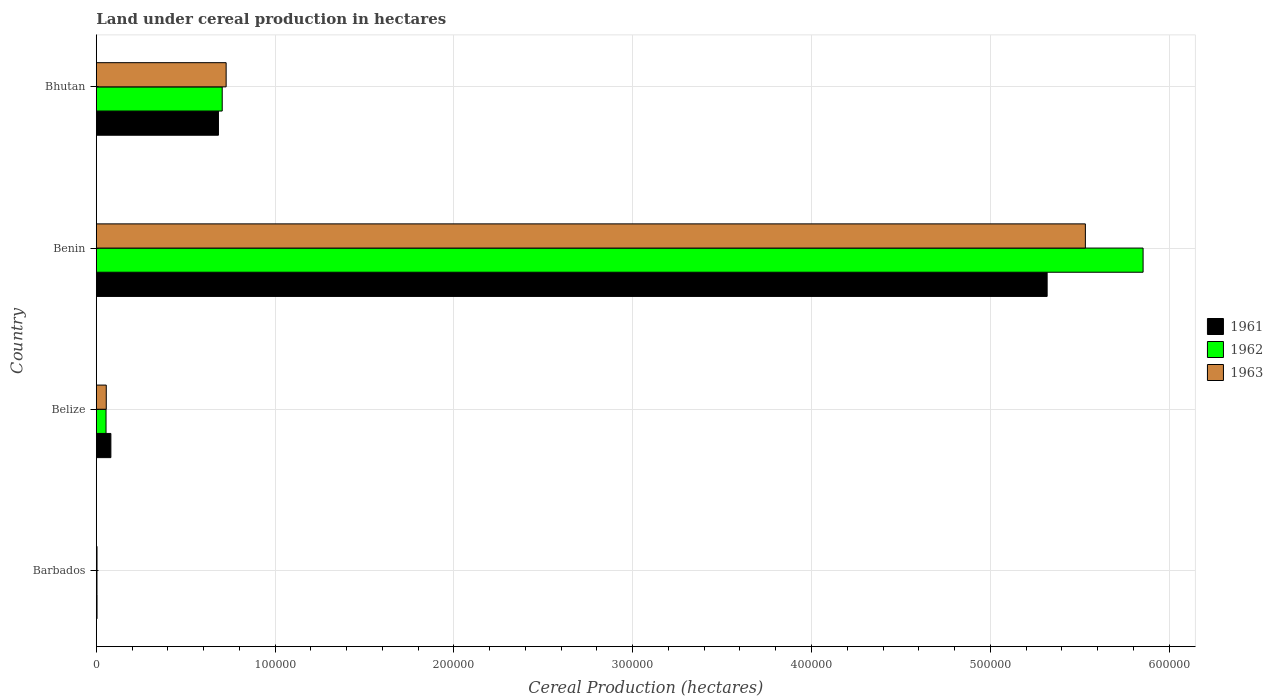How many groups of bars are there?
Provide a short and direct response. 4. How many bars are there on the 4th tick from the top?
Your response must be concise. 3. How many bars are there on the 4th tick from the bottom?
Keep it short and to the point. 3. What is the label of the 4th group of bars from the top?
Provide a short and direct response. Barbados. In how many cases, is the number of bars for a given country not equal to the number of legend labels?
Keep it short and to the point. 0. What is the land under cereal production in 1962 in Benin?
Provide a succinct answer. 5.85e+05. Across all countries, what is the maximum land under cereal production in 1963?
Make the answer very short. 5.53e+05. Across all countries, what is the minimum land under cereal production in 1962?
Ensure brevity in your answer.  358. In which country was the land under cereal production in 1962 maximum?
Keep it short and to the point. Benin. In which country was the land under cereal production in 1961 minimum?
Offer a very short reply. Barbados. What is the total land under cereal production in 1963 in the graph?
Offer a terse response. 6.32e+05. What is the difference between the land under cereal production in 1961 in Belize and that in Bhutan?
Provide a succinct answer. -6.02e+04. What is the difference between the land under cereal production in 1961 in Bhutan and the land under cereal production in 1963 in Barbados?
Provide a short and direct response. 6.79e+04. What is the average land under cereal production in 1962 per country?
Make the answer very short. 1.65e+05. What is the difference between the land under cereal production in 1961 and land under cereal production in 1962 in Benin?
Keep it short and to the point. -5.37e+04. What is the ratio of the land under cereal production in 1962 in Belize to that in Bhutan?
Give a very brief answer. 0.08. Is the difference between the land under cereal production in 1961 in Barbados and Bhutan greater than the difference between the land under cereal production in 1962 in Barbados and Bhutan?
Your answer should be compact. Yes. What is the difference between the highest and the second highest land under cereal production in 1962?
Your answer should be very brief. 5.15e+05. What is the difference between the highest and the lowest land under cereal production in 1962?
Keep it short and to the point. 5.85e+05. In how many countries, is the land under cereal production in 1961 greater than the average land under cereal production in 1961 taken over all countries?
Your answer should be compact. 1. Is the sum of the land under cereal production in 1963 in Barbados and Bhutan greater than the maximum land under cereal production in 1961 across all countries?
Give a very brief answer. No. How many bars are there?
Your answer should be compact. 12. How many countries are there in the graph?
Make the answer very short. 4. Are the values on the major ticks of X-axis written in scientific E-notation?
Make the answer very short. No. Does the graph contain grids?
Keep it short and to the point. Yes. Where does the legend appear in the graph?
Your response must be concise. Center right. How are the legend labels stacked?
Provide a succinct answer. Vertical. What is the title of the graph?
Ensure brevity in your answer.  Land under cereal production in hectares. Does "2012" appear as one of the legend labels in the graph?
Provide a short and direct response. No. What is the label or title of the X-axis?
Ensure brevity in your answer.  Cereal Production (hectares). What is the Cereal Production (hectares) of 1961 in Barbados?
Your answer should be compact. 380. What is the Cereal Production (hectares) in 1962 in Barbados?
Provide a short and direct response. 358. What is the Cereal Production (hectares) of 1963 in Barbados?
Give a very brief answer. 376. What is the Cereal Production (hectares) of 1961 in Belize?
Offer a terse response. 8129. What is the Cereal Production (hectares) in 1962 in Belize?
Your response must be concise. 5419. What is the Cereal Production (hectares) of 1963 in Belize?
Your response must be concise. 5550. What is the Cereal Production (hectares) in 1961 in Benin?
Offer a terse response. 5.32e+05. What is the Cereal Production (hectares) of 1962 in Benin?
Your answer should be compact. 5.85e+05. What is the Cereal Production (hectares) in 1963 in Benin?
Keep it short and to the point. 5.53e+05. What is the Cereal Production (hectares) of 1961 in Bhutan?
Make the answer very short. 6.83e+04. What is the Cereal Production (hectares) in 1962 in Bhutan?
Keep it short and to the point. 7.04e+04. What is the Cereal Production (hectares) of 1963 in Bhutan?
Ensure brevity in your answer.  7.26e+04. Across all countries, what is the maximum Cereal Production (hectares) in 1961?
Provide a short and direct response. 5.32e+05. Across all countries, what is the maximum Cereal Production (hectares) in 1962?
Offer a terse response. 5.85e+05. Across all countries, what is the maximum Cereal Production (hectares) of 1963?
Make the answer very short. 5.53e+05. Across all countries, what is the minimum Cereal Production (hectares) of 1961?
Offer a terse response. 380. Across all countries, what is the minimum Cereal Production (hectares) in 1962?
Keep it short and to the point. 358. Across all countries, what is the minimum Cereal Production (hectares) in 1963?
Ensure brevity in your answer.  376. What is the total Cereal Production (hectares) of 1961 in the graph?
Offer a terse response. 6.09e+05. What is the total Cereal Production (hectares) in 1962 in the graph?
Make the answer very short. 6.62e+05. What is the total Cereal Production (hectares) of 1963 in the graph?
Provide a succinct answer. 6.32e+05. What is the difference between the Cereal Production (hectares) in 1961 in Barbados and that in Belize?
Provide a succinct answer. -7749. What is the difference between the Cereal Production (hectares) in 1962 in Barbados and that in Belize?
Offer a terse response. -5061. What is the difference between the Cereal Production (hectares) of 1963 in Barbados and that in Belize?
Make the answer very short. -5174. What is the difference between the Cereal Production (hectares) in 1961 in Barbados and that in Benin?
Your answer should be compact. -5.31e+05. What is the difference between the Cereal Production (hectares) of 1962 in Barbados and that in Benin?
Offer a terse response. -5.85e+05. What is the difference between the Cereal Production (hectares) of 1963 in Barbados and that in Benin?
Offer a very short reply. -5.53e+05. What is the difference between the Cereal Production (hectares) of 1961 in Barbados and that in Bhutan?
Keep it short and to the point. -6.79e+04. What is the difference between the Cereal Production (hectares) in 1962 in Barbados and that in Bhutan?
Offer a very short reply. -7.00e+04. What is the difference between the Cereal Production (hectares) of 1963 in Barbados and that in Bhutan?
Keep it short and to the point. -7.22e+04. What is the difference between the Cereal Production (hectares) in 1961 in Belize and that in Benin?
Offer a very short reply. -5.24e+05. What is the difference between the Cereal Production (hectares) in 1962 in Belize and that in Benin?
Your answer should be very brief. -5.80e+05. What is the difference between the Cereal Production (hectares) of 1963 in Belize and that in Benin?
Give a very brief answer. -5.48e+05. What is the difference between the Cereal Production (hectares) in 1961 in Belize and that in Bhutan?
Your answer should be compact. -6.02e+04. What is the difference between the Cereal Production (hectares) of 1962 in Belize and that in Bhutan?
Keep it short and to the point. -6.50e+04. What is the difference between the Cereal Production (hectares) of 1963 in Belize and that in Bhutan?
Provide a short and direct response. -6.70e+04. What is the difference between the Cereal Production (hectares) of 1961 in Benin and that in Bhutan?
Make the answer very short. 4.64e+05. What is the difference between the Cereal Production (hectares) in 1962 in Benin and that in Bhutan?
Make the answer very short. 5.15e+05. What is the difference between the Cereal Production (hectares) of 1963 in Benin and that in Bhutan?
Your answer should be very brief. 4.81e+05. What is the difference between the Cereal Production (hectares) of 1961 in Barbados and the Cereal Production (hectares) of 1962 in Belize?
Your response must be concise. -5039. What is the difference between the Cereal Production (hectares) of 1961 in Barbados and the Cereal Production (hectares) of 1963 in Belize?
Your answer should be very brief. -5170. What is the difference between the Cereal Production (hectares) in 1962 in Barbados and the Cereal Production (hectares) in 1963 in Belize?
Give a very brief answer. -5192. What is the difference between the Cereal Production (hectares) of 1961 in Barbados and the Cereal Production (hectares) of 1962 in Benin?
Keep it short and to the point. -5.85e+05. What is the difference between the Cereal Production (hectares) of 1961 in Barbados and the Cereal Production (hectares) of 1963 in Benin?
Your answer should be very brief. -5.53e+05. What is the difference between the Cereal Production (hectares) in 1962 in Barbados and the Cereal Production (hectares) in 1963 in Benin?
Your response must be concise. -5.53e+05. What is the difference between the Cereal Production (hectares) of 1961 in Barbados and the Cereal Production (hectares) of 1962 in Bhutan?
Your answer should be compact. -7.00e+04. What is the difference between the Cereal Production (hectares) in 1961 in Barbados and the Cereal Production (hectares) in 1963 in Bhutan?
Ensure brevity in your answer.  -7.22e+04. What is the difference between the Cereal Production (hectares) of 1962 in Barbados and the Cereal Production (hectares) of 1963 in Bhutan?
Provide a short and direct response. -7.22e+04. What is the difference between the Cereal Production (hectares) in 1961 in Belize and the Cereal Production (hectares) in 1962 in Benin?
Keep it short and to the point. -5.77e+05. What is the difference between the Cereal Production (hectares) in 1961 in Belize and the Cereal Production (hectares) in 1963 in Benin?
Make the answer very short. -5.45e+05. What is the difference between the Cereal Production (hectares) in 1962 in Belize and the Cereal Production (hectares) in 1963 in Benin?
Your answer should be very brief. -5.48e+05. What is the difference between the Cereal Production (hectares) of 1961 in Belize and the Cereal Production (hectares) of 1962 in Bhutan?
Provide a succinct answer. -6.23e+04. What is the difference between the Cereal Production (hectares) of 1961 in Belize and the Cereal Production (hectares) of 1963 in Bhutan?
Keep it short and to the point. -6.45e+04. What is the difference between the Cereal Production (hectares) of 1962 in Belize and the Cereal Production (hectares) of 1963 in Bhutan?
Your answer should be very brief. -6.72e+04. What is the difference between the Cereal Production (hectares) in 1961 in Benin and the Cereal Production (hectares) in 1962 in Bhutan?
Provide a succinct answer. 4.61e+05. What is the difference between the Cereal Production (hectares) of 1961 in Benin and the Cereal Production (hectares) of 1963 in Bhutan?
Offer a very short reply. 4.59e+05. What is the difference between the Cereal Production (hectares) in 1962 in Benin and the Cereal Production (hectares) in 1963 in Bhutan?
Offer a terse response. 5.13e+05. What is the average Cereal Production (hectares) in 1961 per country?
Provide a succinct answer. 1.52e+05. What is the average Cereal Production (hectares) in 1962 per country?
Offer a terse response. 1.65e+05. What is the average Cereal Production (hectares) of 1963 per country?
Provide a short and direct response. 1.58e+05. What is the difference between the Cereal Production (hectares) of 1962 and Cereal Production (hectares) of 1963 in Barbados?
Your answer should be compact. -18. What is the difference between the Cereal Production (hectares) in 1961 and Cereal Production (hectares) in 1962 in Belize?
Provide a succinct answer. 2710. What is the difference between the Cereal Production (hectares) in 1961 and Cereal Production (hectares) in 1963 in Belize?
Your answer should be compact. 2579. What is the difference between the Cereal Production (hectares) of 1962 and Cereal Production (hectares) of 1963 in Belize?
Offer a very short reply. -131. What is the difference between the Cereal Production (hectares) in 1961 and Cereal Production (hectares) in 1962 in Benin?
Keep it short and to the point. -5.37e+04. What is the difference between the Cereal Production (hectares) of 1961 and Cereal Production (hectares) of 1963 in Benin?
Make the answer very short. -2.14e+04. What is the difference between the Cereal Production (hectares) of 1962 and Cereal Production (hectares) of 1963 in Benin?
Your answer should be very brief. 3.23e+04. What is the difference between the Cereal Production (hectares) in 1961 and Cereal Production (hectares) in 1962 in Bhutan?
Give a very brief answer. -2100. What is the difference between the Cereal Production (hectares) of 1961 and Cereal Production (hectares) of 1963 in Bhutan?
Keep it short and to the point. -4300. What is the difference between the Cereal Production (hectares) in 1962 and Cereal Production (hectares) in 1963 in Bhutan?
Offer a terse response. -2200. What is the ratio of the Cereal Production (hectares) of 1961 in Barbados to that in Belize?
Make the answer very short. 0.05. What is the ratio of the Cereal Production (hectares) in 1962 in Barbados to that in Belize?
Provide a short and direct response. 0.07. What is the ratio of the Cereal Production (hectares) of 1963 in Barbados to that in Belize?
Your answer should be very brief. 0.07. What is the ratio of the Cereal Production (hectares) of 1961 in Barbados to that in Benin?
Keep it short and to the point. 0. What is the ratio of the Cereal Production (hectares) of 1962 in Barbados to that in Benin?
Offer a terse response. 0. What is the ratio of the Cereal Production (hectares) of 1963 in Barbados to that in Benin?
Your answer should be very brief. 0. What is the ratio of the Cereal Production (hectares) of 1961 in Barbados to that in Bhutan?
Make the answer very short. 0.01. What is the ratio of the Cereal Production (hectares) of 1962 in Barbados to that in Bhutan?
Keep it short and to the point. 0.01. What is the ratio of the Cereal Production (hectares) of 1963 in Barbados to that in Bhutan?
Make the answer very short. 0.01. What is the ratio of the Cereal Production (hectares) in 1961 in Belize to that in Benin?
Your response must be concise. 0.02. What is the ratio of the Cereal Production (hectares) in 1962 in Belize to that in Benin?
Give a very brief answer. 0.01. What is the ratio of the Cereal Production (hectares) in 1963 in Belize to that in Benin?
Offer a terse response. 0.01. What is the ratio of the Cereal Production (hectares) in 1961 in Belize to that in Bhutan?
Provide a succinct answer. 0.12. What is the ratio of the Cereal Production (hectares) of 1962 in Belize to that in Bhutan?
Provide a short and direct response. 0.08. What is the ratio of the Cereal Production (hectares) in 1963 in Belize to that in Bhutan?
Provide a short and direct response. 0.08. What is the ratio of the Cereal Production (hectares) in 1961 in Benin to that in Bhutan?
Keep it short and to the point. 7.79. What is the ratio of the Cereal Production (hectares) of 1962 in Benin to that in Bhutan?
Provide a succinct answer. 8.32. What is the ratio of the Cereal Production (hectares) in 1963 in Benin to that in Bhutan?
Your response must be concise. 7.62. What is the difference between the highest and the second highest Cereal Production (hectares) in 1961?
Offer a terse response. 4.64e+05. What is the difference between the highest and the second highest Cereal Production (hectares) in 1962?
Your response must be concise. 5.15e+05. What is the difference between the highest and the second highest Cereal Production (hectares) in 1963?
Offer a terse response. 4.81e+05. What is the difference between the highest and the lowest Cereal Production (hectares) of 1961?
Your response must be concise. 5.31e+05. What is the difference between the highest and the lowest Cereal Production (hectares) of 1962?
Make the answer very short. 5.85e+05. What is the difference between the highest and the lowest Cereal Production (hectares) in 1963?
Provide a succinct answer. 5.53e+05. 